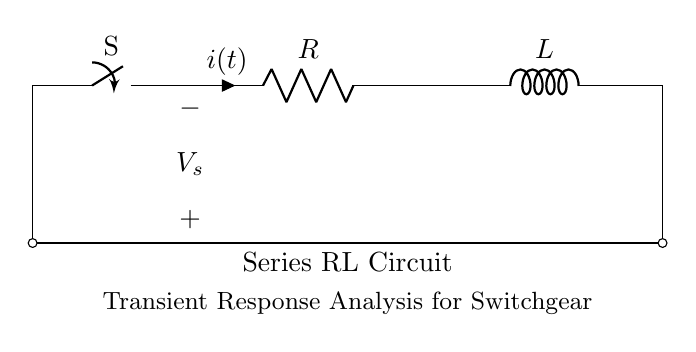What are the components in the circuit? The circuit contains a resistor (R) and an inductor (L) connected in series. These are the basic passive components depicted in the diagram.
Answer: Resistor and inductor What is the role of the switch in the circuit? The switch controls the flow of current in the circuit, either allowing or interrupting it. When closed, it connects the voltage source to the circuit; when open, it disconnects them.
Answer: Control current flow What is the current direction indicated in the circuit? The current direction, as indicated by the arrow on the circuit, flows from the positive terminal of the voltage source through the switch, resistor, and inductor, returning to the negative terminal.
Answer: Clockwise What does the symbol V_s represent in the circuit? The symbol V_s represents the source voltage applied across the circuit. It is the potential difference supplied by the voltage source, which drives the current through the components.
Answer: Source voltage How does the inductor affect the circuit during switching? The inductor resists changes in current flow due to its property of self-inductance. When the switch is closed, it initially opposes the increase in current, creating a transient response characterized by a time delay before reaching steady state.
Answer: Resists current change What is the time constant of the series RL circuit? The time constant (τ) of a series RL circuit is given by the formula τ = L/R, where L is inductance and R is resistance. This time constant signifies how quickly the circuit responds to changes in current.
Answer: L/R What type of response is analyzed in switchgear operations? The transient response is analyzed, as it describes how the circuit behaves momentarily after a change, such as closing or opening the switch, before stabilizing to a steady-state condition.
Answer: Transient response 